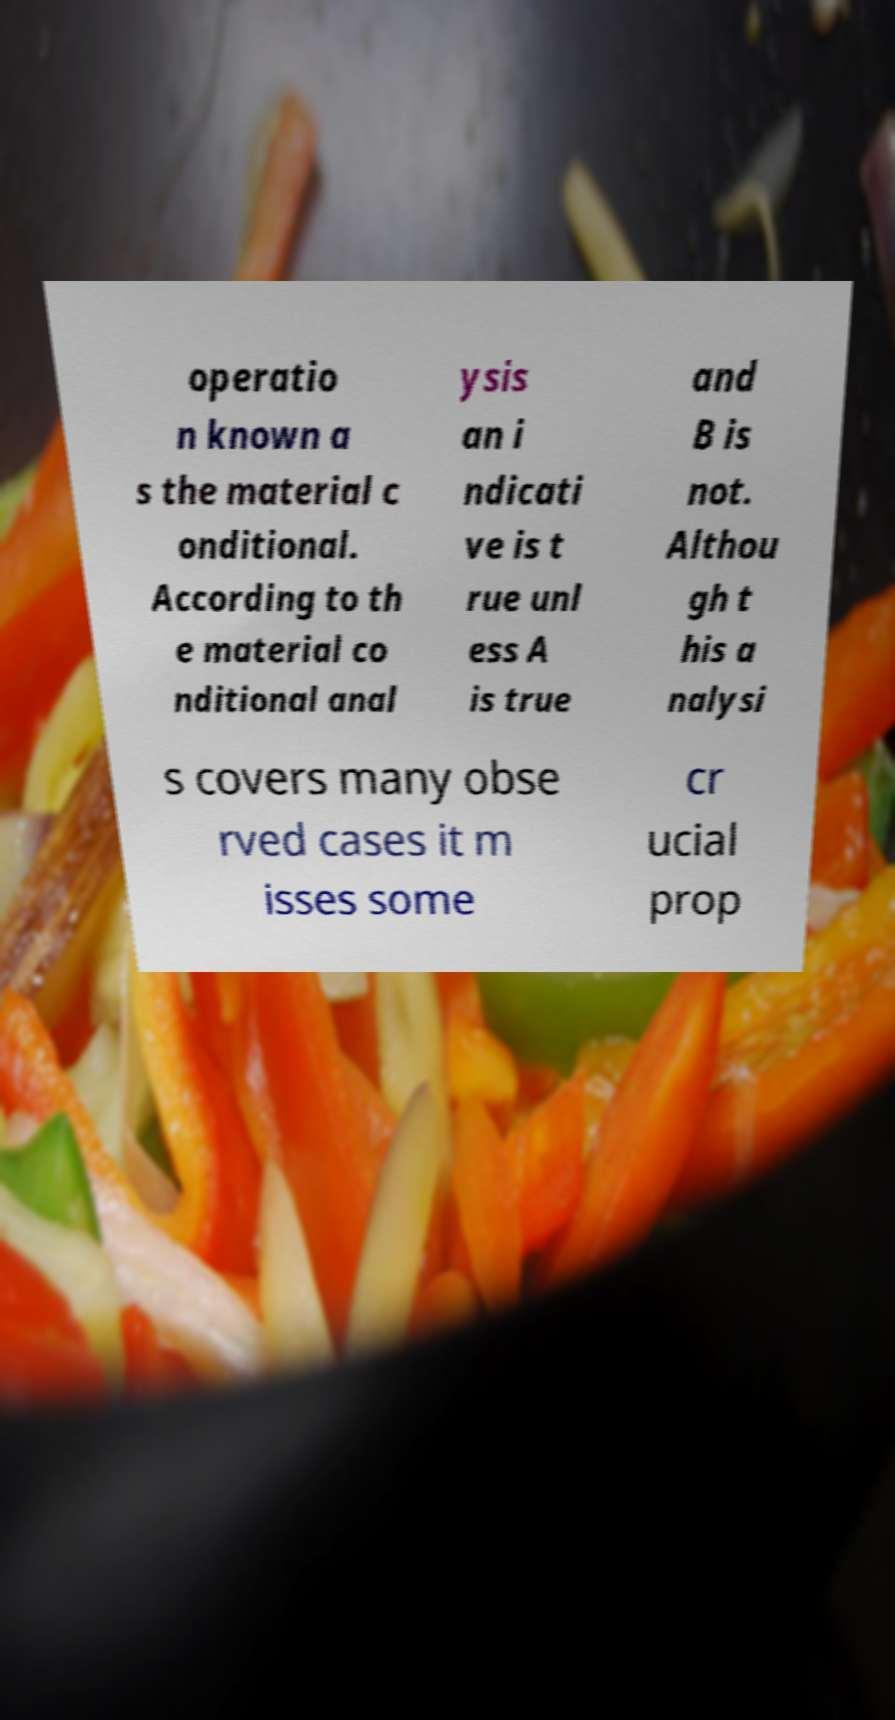Could you assist in decoding the text presented in this image and type it out clearly? operatio n known a s the material c onditional. According to th e material co nditional anal ysis an i ndicati ve is t rue unl ess A is true and B is not. Althou gh t his a nalysi s covers many obse rved cases it m isses some cr ucial prop 